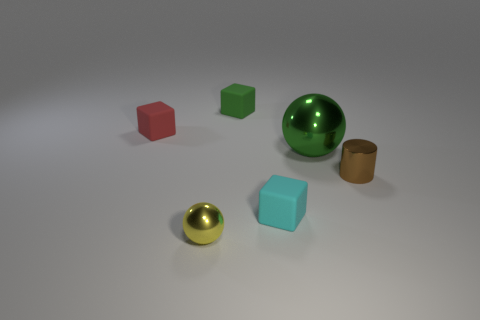Add 3 big purple rubber cubes. How many objects exist? 9 Subtract all cylinders. How many objects are left? 5 Subtract 1 brown cylinders. How many objects are left? 5 Subtract all big yellow matte cylinders. Subtract all small green matte things. How many objects are left? 5 Add 3 green spheres. How many green spheres are left? 4 Add 3 yellow balls. How many yellow balls exist? 4 